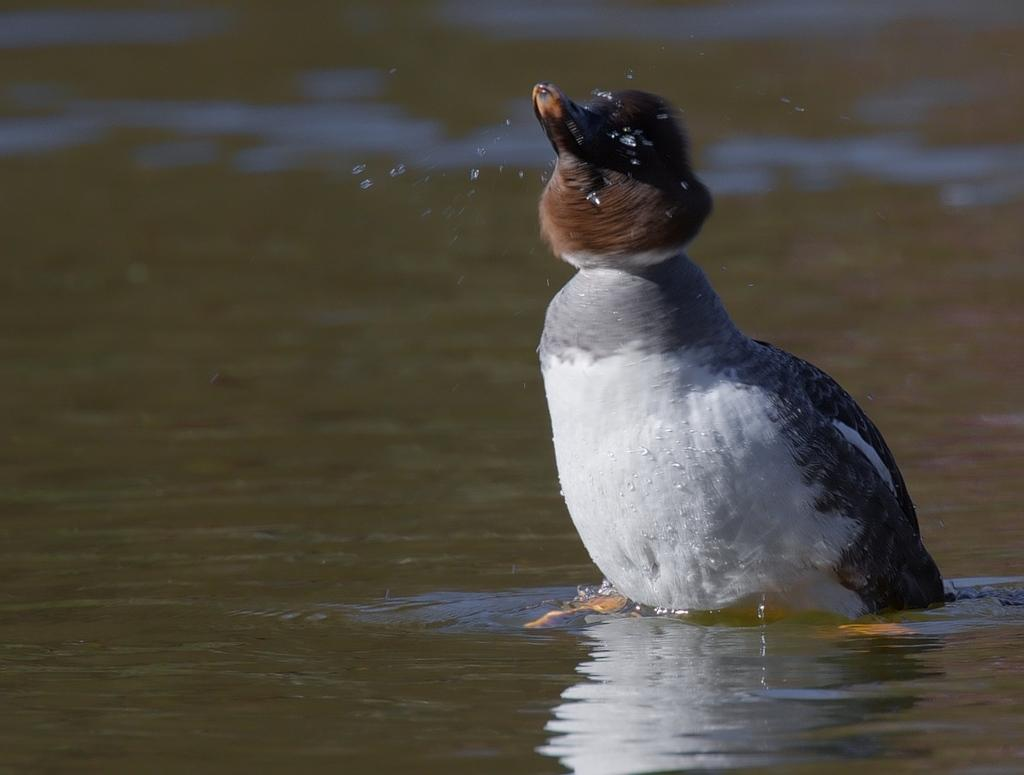What is the main subject in the center of the image? There is a bird in the center of the image. What can be seen at the bottom of the image? There is water at the bottom of the image. What type of furniture is visible in the image? There is no furniture present in the image; it features a bird and water. What statement does the bird make in the image? The image does not depict the bird making any statements; it is a still image of a bird and water. 